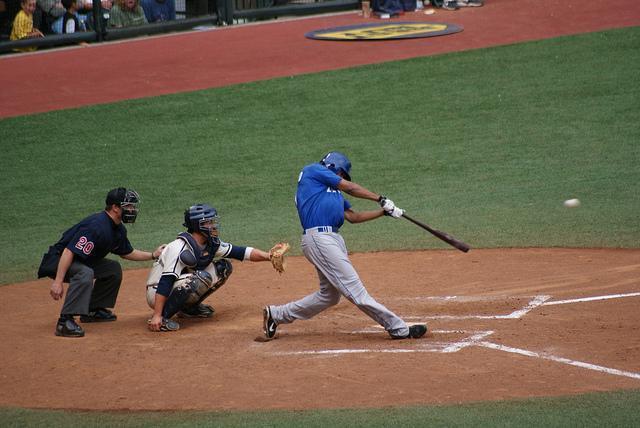What is the gear called that the umpire is wearing on his face?
Choose the correct response and explain in the format: 'Answer: answer
Rationale: rationale.'
Options: Glasses, goggles, umpire mask, binoculars. Answer: umpire mask.
Rationale: The gear is the umpire mask. 